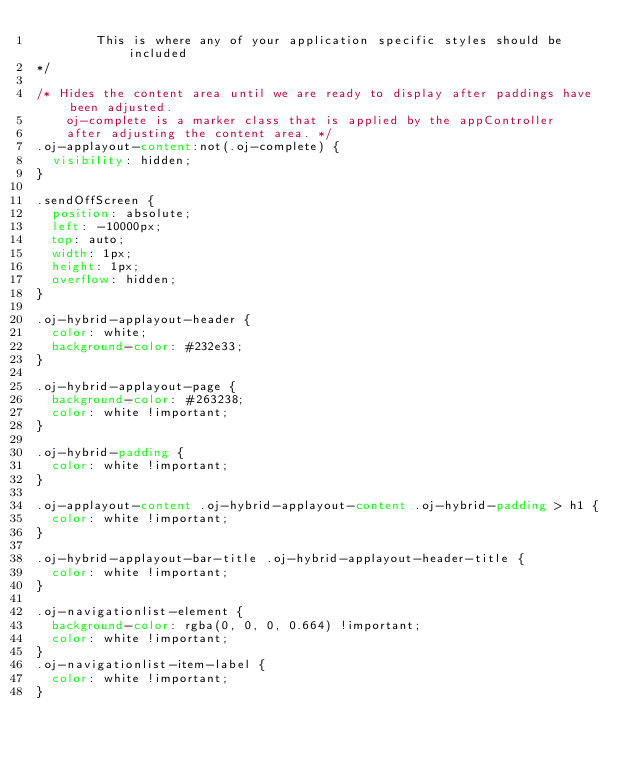Convert code to text. <code><loc_0><loc_0><loc_500><loc_500><_CSS_>        This is where any of your application specific styles should be included
*/

/* Hides the content area until we are ready to display after paddings have been adjusted. 
    oj-complete is a marker class that is applied by the appController 
    after adjusting the content area. */
.oj-applayout-content:not(.oj-complete) {
  visibility: hidden;
}

.sendOffScreen {
  position: absolute;
  left: -10000px;
  top: auto;
  width: 1px;
  height: 1px;
  overflow: hidden;
}

.oj-hybrid-applayout-header {
  color: white;
  background-color: #232e33;
}

.oj-hybrid-applayout-page {
  background-color: #263238;
  color: white !important;
}

.oj-hybrid-padding {
  color: white !important;
}

.oj-applayout-content .oj-hybrid-applayout-content .oj-hybrid-padding > h1 {
  color: white !important;
}

.oj-hybrid-applayout-bar-title .oj-hybrid-applayout-header-title {
  color: white !important;
}

.oj-navigationlist-element {
  background-color: rgba(0, 0, 0, 0.664) !important;
  color: white !important;
}
.oj-navigationlist-item-label {
  color: white !important;
}
</code> 